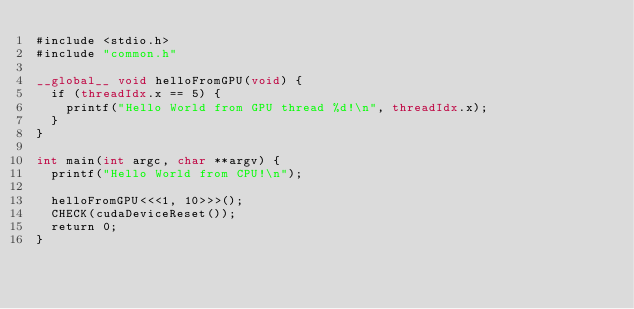Convert code to text. <code><loc_0><loc_0><loc_500><loc_500><_Cuda_>#include <stdio.h>
#include "common.h"

__global__ void helloFromGPU(void) {
  if (threadIdx.x == 5) {
    printf("Hello World from GPU thread %d!\n", threadIdx.x);
  }
}

int main(int argc, char **argv) {
  printf("Hello World from CPU!\n");

  helloFromGPU<<<1, 10>>>();
  CHECK(cudaDeviceReset());
  return 0;
}
</code> 